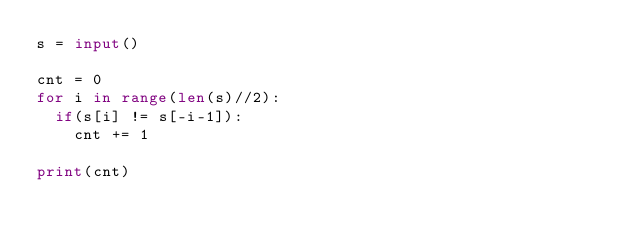Convert code to text. <code><loc_0><loc_0><loc_500><loc_500><_Python_>s = input()

cnt = 0
for i in range(len(s)//2):
  if(s[i] != s[-i-1]):
    cnt += 1

print(cnt)</code> 